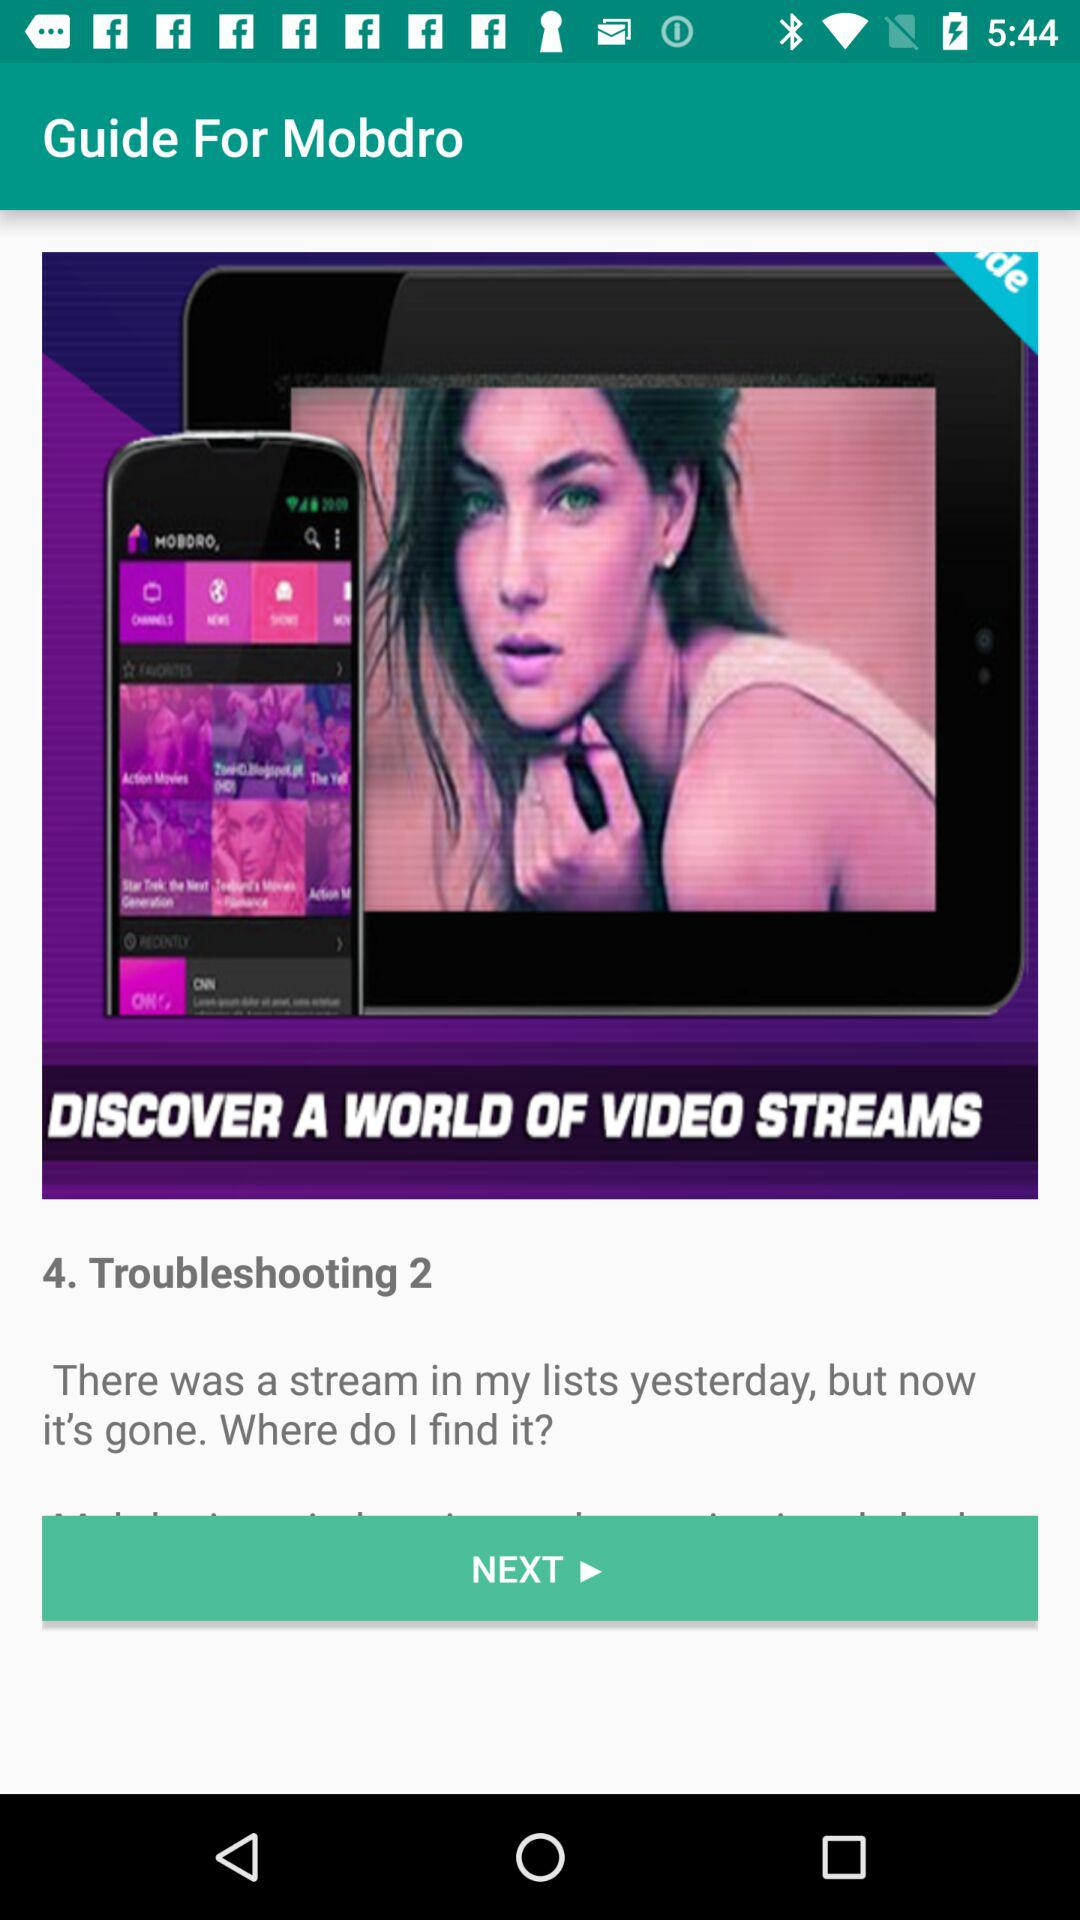What is the app name? The app name is "Guide For Mobdro". 